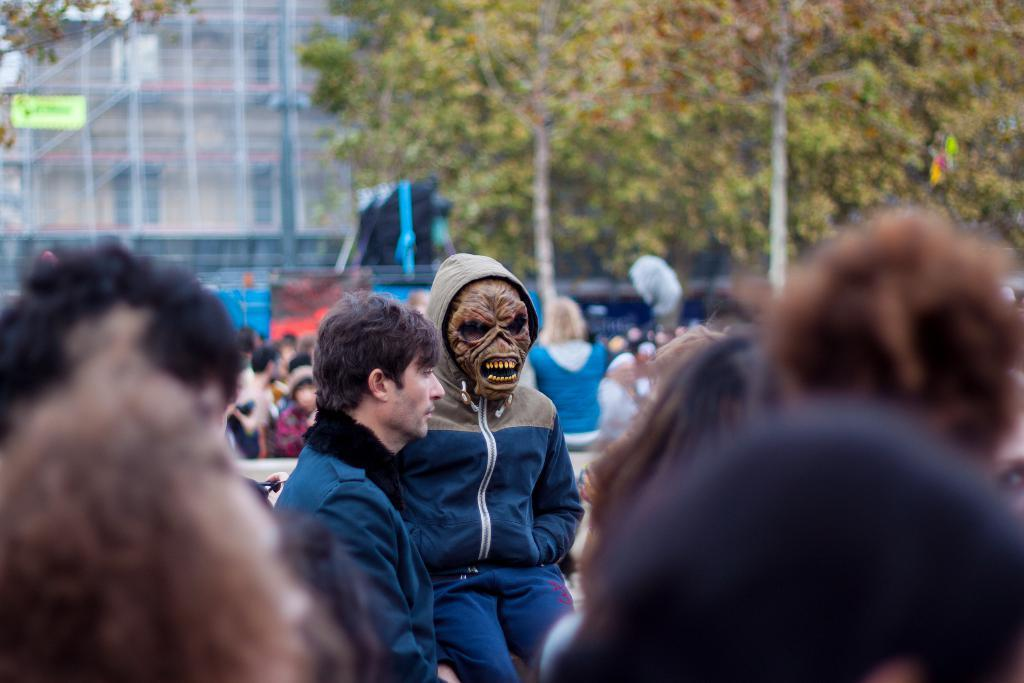How many people are in the image? There are people in the image, but the exact number is not specified. What is one person wearing in the image? One person is wearing a mask in the image. What type of natural elements can be seen in the image? There are trees in the image. What type of man-made structures can be seen in the image? There are poles and a building in the image. How would you describe the background of the image? The background is blurred in the image. What type of light can be seen on the building in the image? There is no mention of any light on the building in the image. 